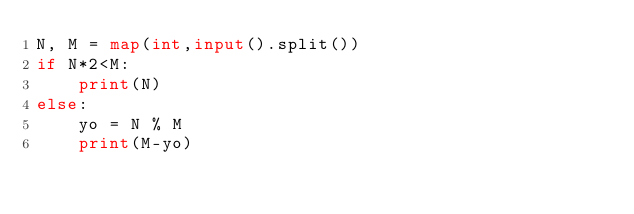Convert code to text. <code><loc_0><loc_0><loc_500><loc_500><_Python_>N, M = map(int,input().split())
if N*2<M:
    print(N)
else:
    yo = N % M
    print(M-yo)</code> 